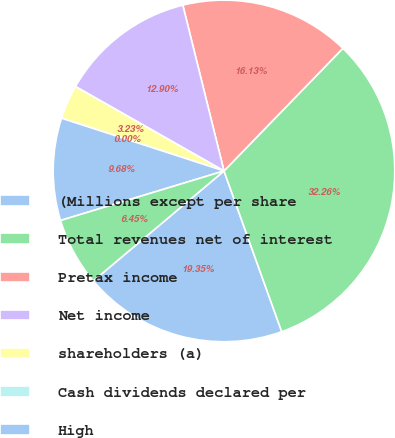Convert chart to OTSL. <chart><loc_0><loc_0><loc_500><loc_500><pie_chart><fcel>(Millions except per share<fcel>Total revenues net of interest<fcel>Pretax income<fcel>Net income<fcel>shareholders (a)<fcel>Cash dividends declared per<fcel>High<fcel>Low<nl><fcel>19.35%<fcel>32.26%<fcel>16.13%<fcel>12.9%<fcel>3.23%<fcel>0.0%<fcel>9.68%<fcel>6.45%<nl></chart> 